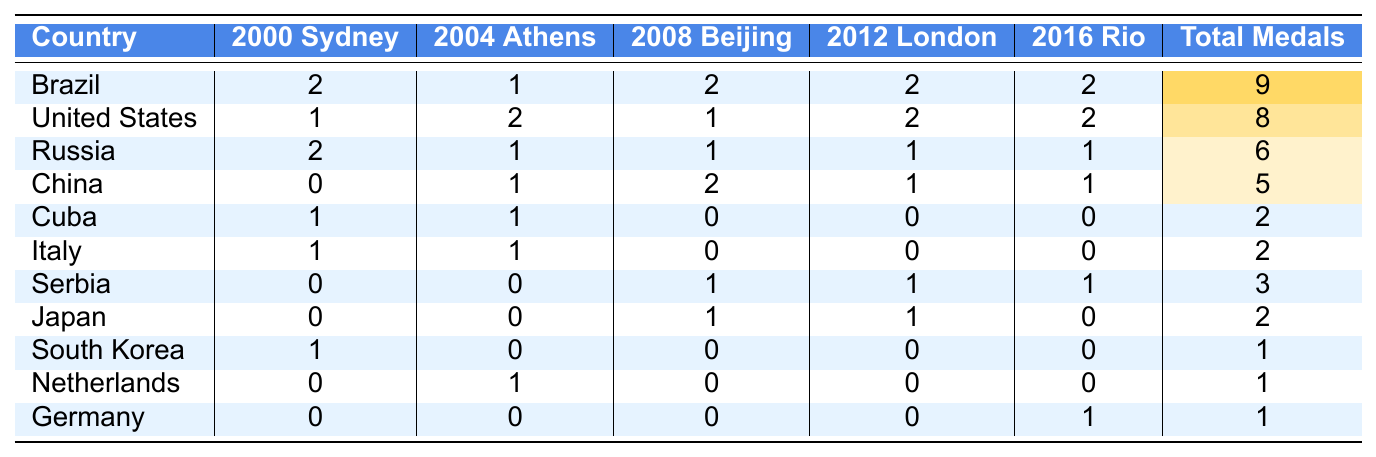What country won the most volleyball medals in total? Looking at the "Total Medals" column, Brazil has the highest total with 9 medals.
Answer: Brazil How many medals did the United States win in the 2004 Athens Olympics? The "2004 Athens" column shows that the United States won 2 medals.
Answer: 2 Which country won exactly 1 medal in the 2016 Rio Olympics? In the "2016 Rio" column, Germany is the only country that won 1 medal.
Answer: Germany What is the total number of medals won by Russia in all five Olympics? Russia's total is listed as 6 in the "Total Medals" column.
Answer: 6 Did China win any medals in the 2000 Sydney Olympics? The "2000 Sydney" column shows a value of 0 for China, indicating they did not win any medals.
Answer: No Which two countries have the same total number of medals, and what is that total? Cuba and Italy both have totals of 2 medals each, found in the "Total Medals" column.
Answer: 2 What was the difference in total medal counts between Brazil and China? Brazil has 9 total medals, while China has 5. The difference is 9 - 5 = 4.
Answer: 4 How many countries won more than 5 total medals? Only Brazil (9) and the United States (8) exceed 5 total medals, giving us 2 countries.
Answer: 2 Which country had the highest number of medals in the 2008 Beijing Olympics? The "2008 Beijing" column shows that Brazil had 2 medals, the highest number in that year.
Answer: Brazil Did Serbia win any medals in the 2004 Athens Olympics? Serbia has a value of 0 in the "2004 Athens" column, meaning they did not win any medals.
Answer: No What is the average number of medals won by Brazil over the five Olympics? Summing Brazil's medals: 2 + 1 + 2 + 2 + 2 = 9. The average is 9/5 = 1.8.
Answer: 1.8 If we exclude Brazil, which country had the highest total medal count? Without Brazil, the United States would have the highest total with 8 medals.
Answer: United States 